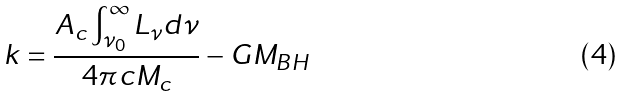<formula> <loc_0><loc_0><loc_500><loc_500>k = \frac { A _ { c } \int _ { \nu _ { 0 } } ^ { \infty } L _ { \nu } d \nu } { 4 \pi c M _ { c } } - G M _ { B H }</formula> 